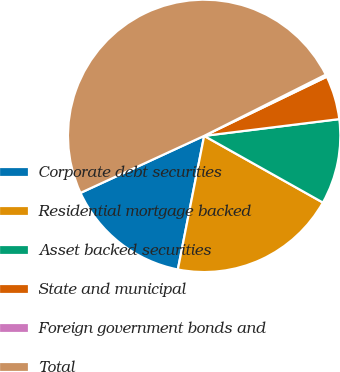<chart> <loc_0><loc_0><loc_500><loc_500><pie_chart><fcel>Corporate debt securities<fcel>Residential mortgage backed<fcel>Asset backed securities<fcel>State and municipal<fcel>Foreign government bonds and<fcel>Total<nl><fcel>15.03%<fcel>19.95%<fcel>10.11%<fcel>5.19%<fcel>0.27%<fcel>49.46%<nl></chart> 